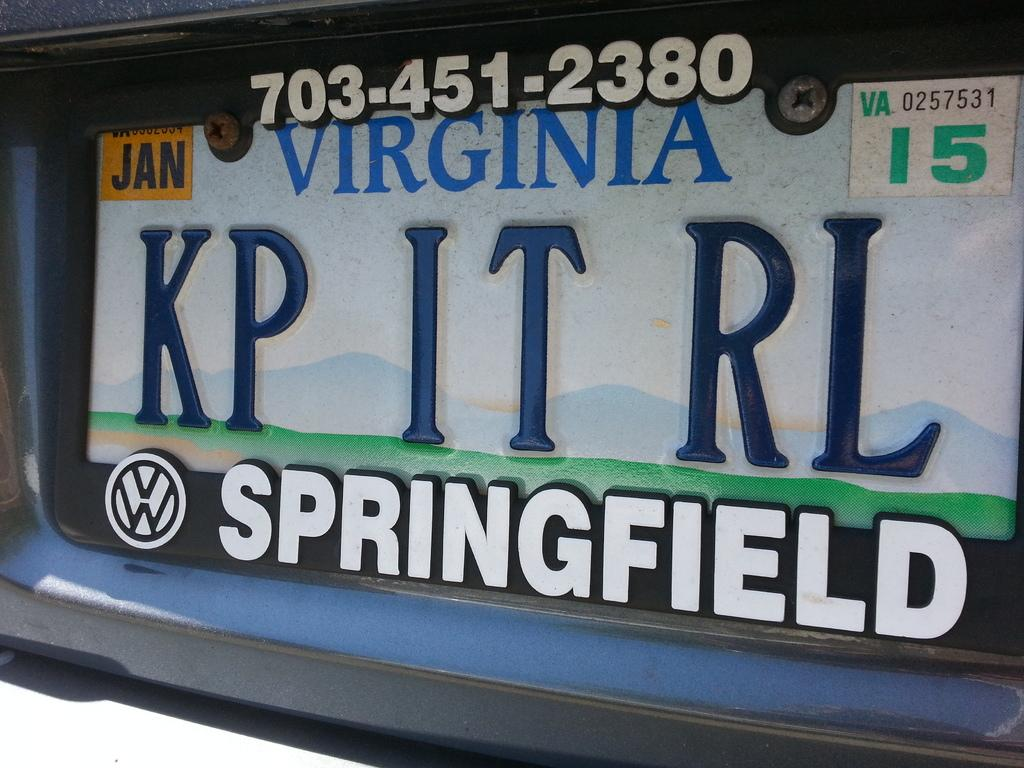Provide a one-sentence caption for the provided image. license plates from the state of virginia  vw car. 